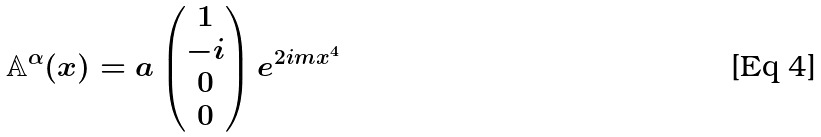<formula> <loc_0><loc_0><loc_500><loc_500>\mathbb { A } ^ { \alpha } ( x ) = a \begin{pmatrix} 1 \\ - i \\ 0 \\ 0 \end{pmatrix} e ^ { 2 i m x ^ { 4 } }</formula> 